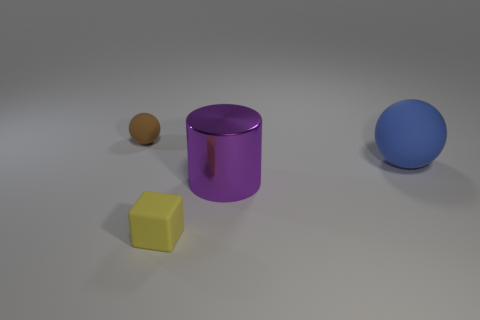Add 3 yellow rubber things. How many objects exist? 7 Subtract all cylinders. How many objects are left? 3 Subtract all large rubber things. Subtract all balls. How many objects are left? 1 Add 2 small yellow rubber blocks. How many small yellow rubber blocks are left? 3 Add 1 blue spheres. How many blue spheres exist? 2 Subtract 1 yellow blocks. How many objects are left? 3 